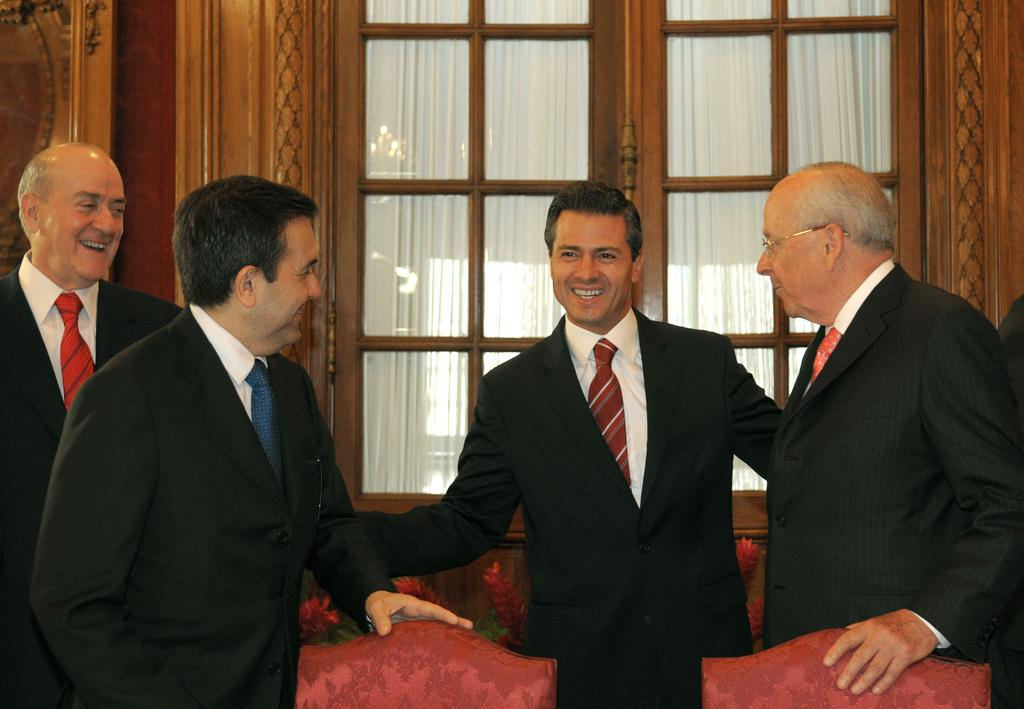How many people are in the image? There are four people in the image. What are the people wearing? The people are wearing black suits. What is the facial expression of the people in the image? The people are smiling. What type of furniture is present in the room? There are chairs in the room. What can be seen in the background of the image? There is a glass window and a white curtain associated with the window in the background. What type of plate is being used by the people in the image? There is no plate present in the image; the people are wearing black suits and smiling. 